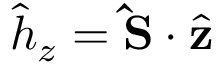Convert formula to latex. <formula><loc_0><loc_0><loc_500><loc_500>\hat { h } _ { z } = { \hat { S } } \cdot \hat { z }</formula> 